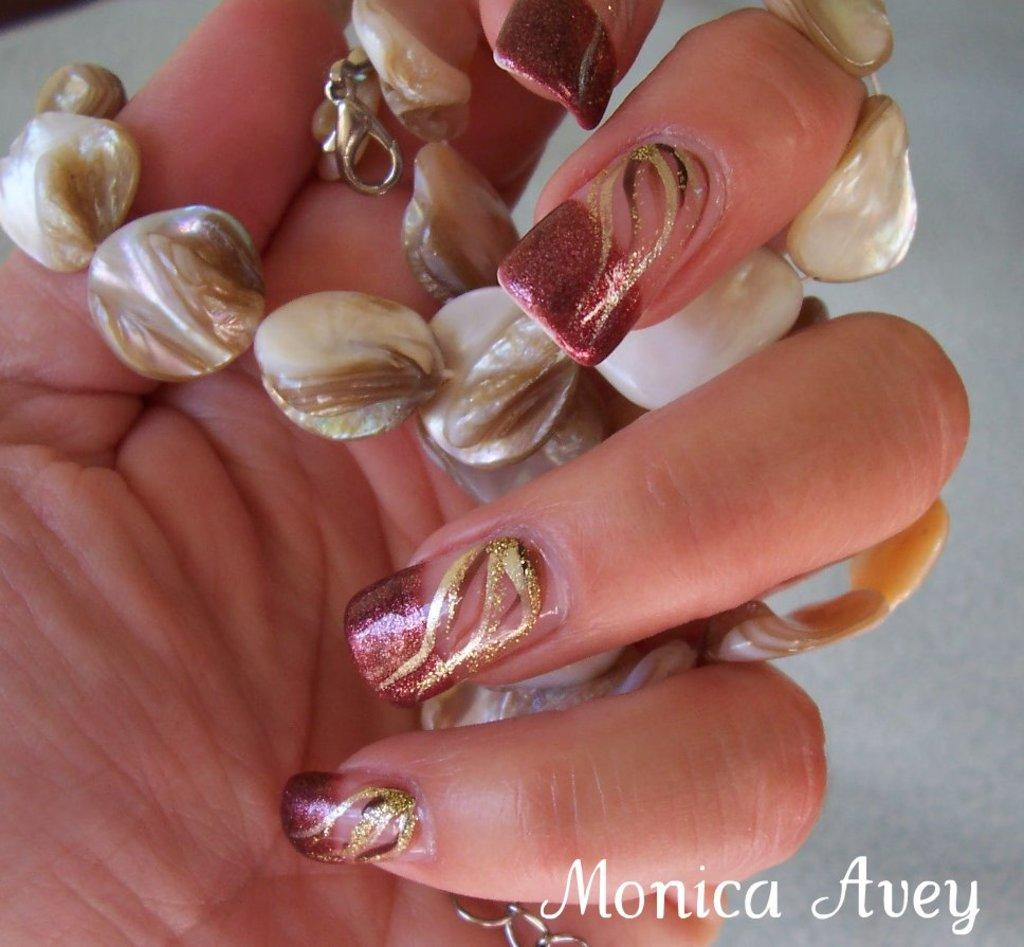<image>
Write a terse but informative summary of the picture. a hand with painted nails and the name 'monica avey' at the bottom of the image 